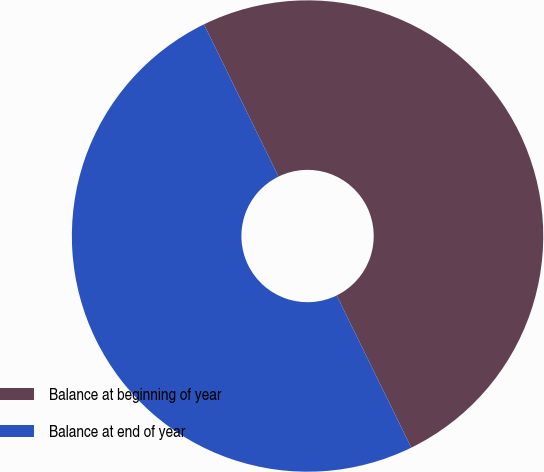Convert chart to OTSL. <chart><loc_0><loc_0><loc_500><loc_500><pie_chart><fcel>Balance at beginning of year<fcel>Balance at end of year<nl><fcel>49.99%<fcel>50.01%<nl></chart> 